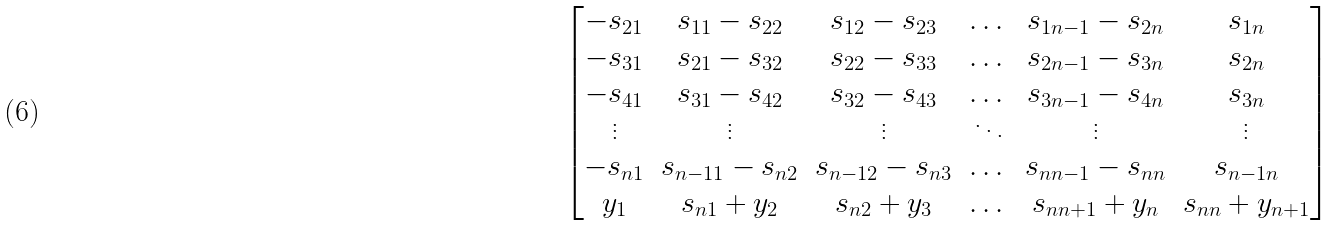Convert formula to latex. <formula><loc_0><loc_0><loc_500><loc_500>\begin{bmatrix} - s _ { 2 1 } & s _ { 1 1 } - s _ { 2 2 } & s _ { 1 2 } - s _ { 2 3 } & \dots & s _ { 1 n - 1 } - s _ { 2 n } & s _ { 1 n } \\ - s _ { 3 1 } & s _ { 2 1 } - s _ { 3 2 } & s _ { 2 2 } - s _ { 3 3 } & \dots & s _ { 2 n - 1 } - s _ { 3 n } & s _ { 2 n } \\ - s _ { 4 1 } & s _ { 3 1 } - s _ { 4 2 } & s _ { 3 2 } - s _ { 4 3 } & \dots & s _ { 3 n - 1 } - s _ { 4 n } & s _ { 3 n } \\ \vdots & \vdots & \vdots & \ddots & \vdots & \vdots \\ - s _ { n 1 } & s _ { n - 1 1 } - s _ { n 2 } & s _ { n - 1 2 } - s _ { n 3 } & \dots & s _ { n n - 1 } - s _ { n n } & s _ { n - 1 n } \\ y _ { 1 } & s _ { n 1 } + y _ { 2 } & s _ { n 2 } + y _ { 3 } & \dots & s _ { n n + 1 } + y _ { n } & s _ { n n } + y _ { n + 1 } \\ \end{bmatrix}</formula> 